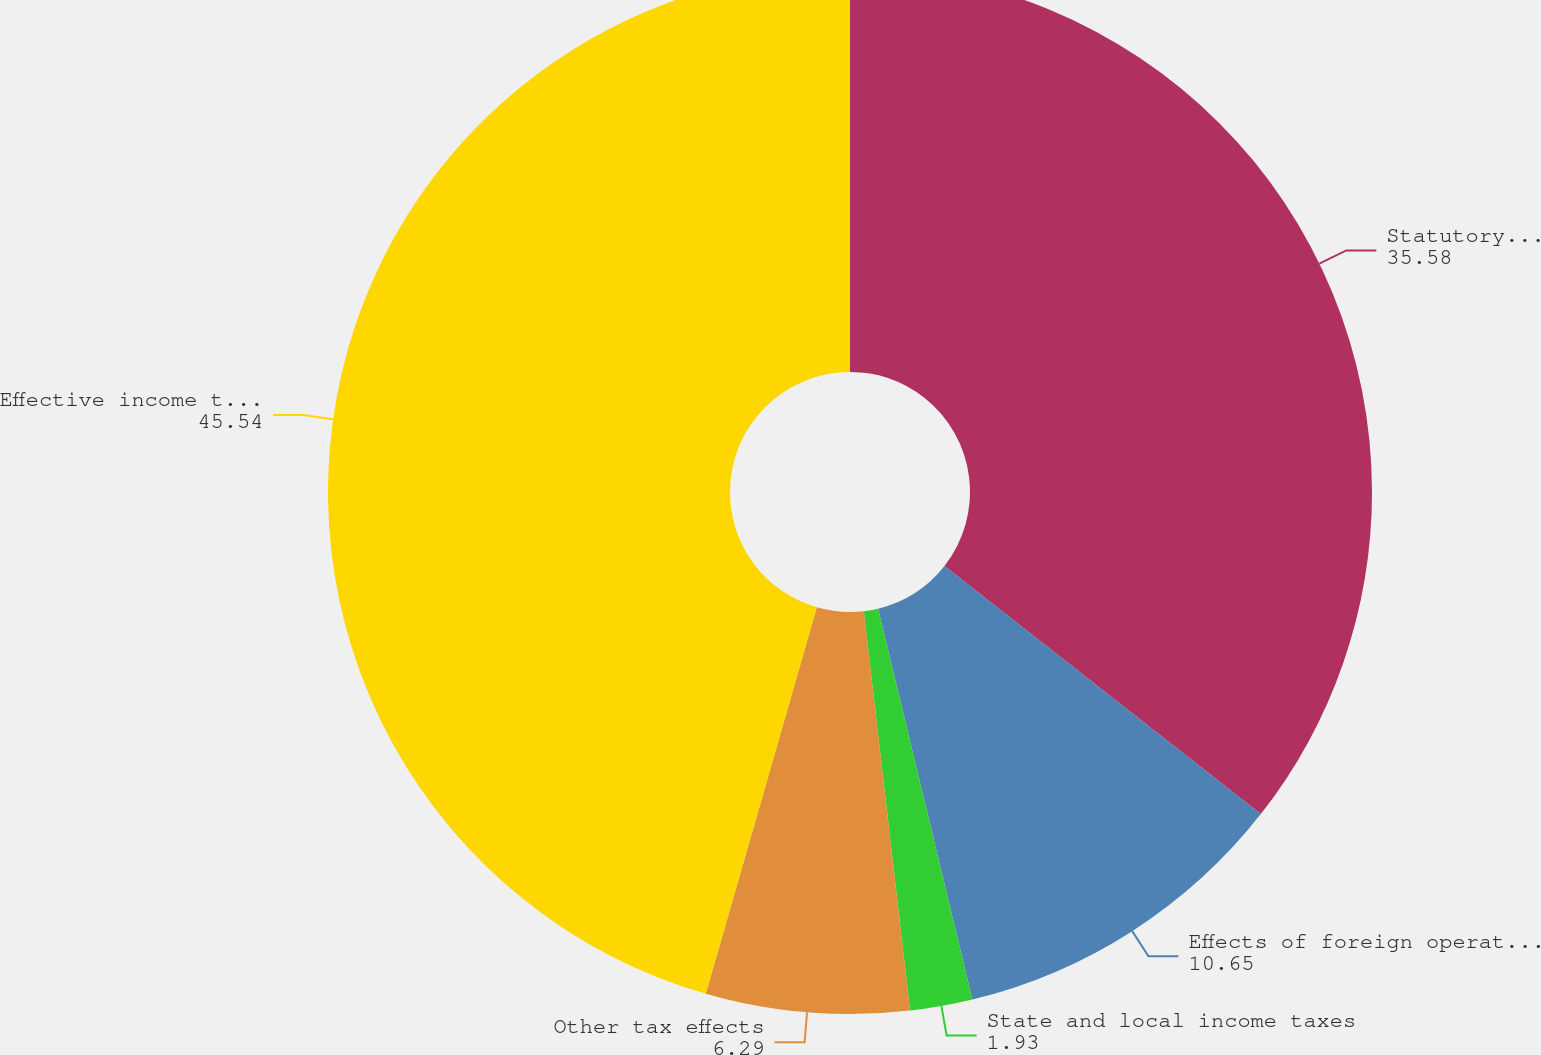Convert chart to OTSL. <chart><loc_0><loc_0><loc_500><loc_500><pie_chart><fcel>Statutory US income tax rate<fcel>Effects of foreign operations<fcel>State and local income taxes<fcel>Other tax effects<fcel>Effective income tax rate for<nl><fcel>35.58%<fcel>10.65%<fcel>1.93%<fcel>6.29%<fcel>45.54%<nl></chart> 